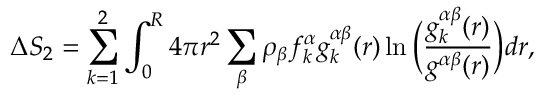<formula> <loc_0><loc_0><loc_500><loc_500>\Delta S _ { 2 } = \sum _ { k = 1 } ^ { 2 } \int _ { 0 } ^ { R } 4 \pi r ^ { 2 } \sum _ { \beta } \rho _ { \beta } f _ { k } ^ { \alpha } g _ { k } ^ { \alpha \beta } ( r ) \ln \left ( \frac { g _ { k } ^ { \alpha \beta } ( r ) } { g ^ { \alpha \beta } ( r ) } \right ) d r ,</formula> 